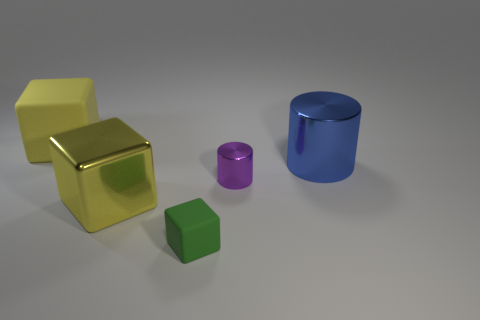Is the cube to the left of the large yellow shiny thing made of the same material as the yellow block in front of the tiny metal thing?
Provide a succinct answer. No. How many matte objects are small cyan spheres or purple objects?
Your answer should be very brief. 0. What material is the yellow cube in front of the large object that is behind the metallic object that is to the right of the tiny cylinder made of?
Your answer should be very brief. Metal. There is a big shiny object left of the small shiny cylinder; is its shape the same as the matte thing to the right of the big yellow rubber object?
Make the answer very short. Yes. What is the color of the rubber block that is right of the yellow object on the left side of the big yellow metal thing?
Your response must be concise. Green. What number of cubes are either yellow matte things or small green things?
Offer a very short reply. 2. There is a large yellow thing in front of the big object that is on the left side of the yellow shiny thing; how many purple objects are on the right side of it?
Ensure brevity in your answer.  1. There is another cube that is the same color as the shiny block; what size is it?
Your answer should be compact. Large. Are there any big purple balls made of the same material as the tiny purple thing?
Keep it short and to the point. No. Is the material of the small block the same as the small purple object?
Keep it short and to the point. No. 